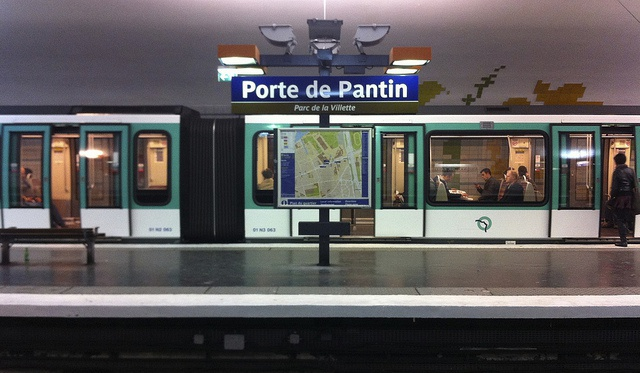Describe the objects in this image and their specific colors. I can see train in gray, black, lightgray, and maroon tones, bench in gray, black, and lightgray tones, people in gray, black, and maroon tones, handbag in black and gray tones, and people in gray, black, maroon, and brown tones in this image. 